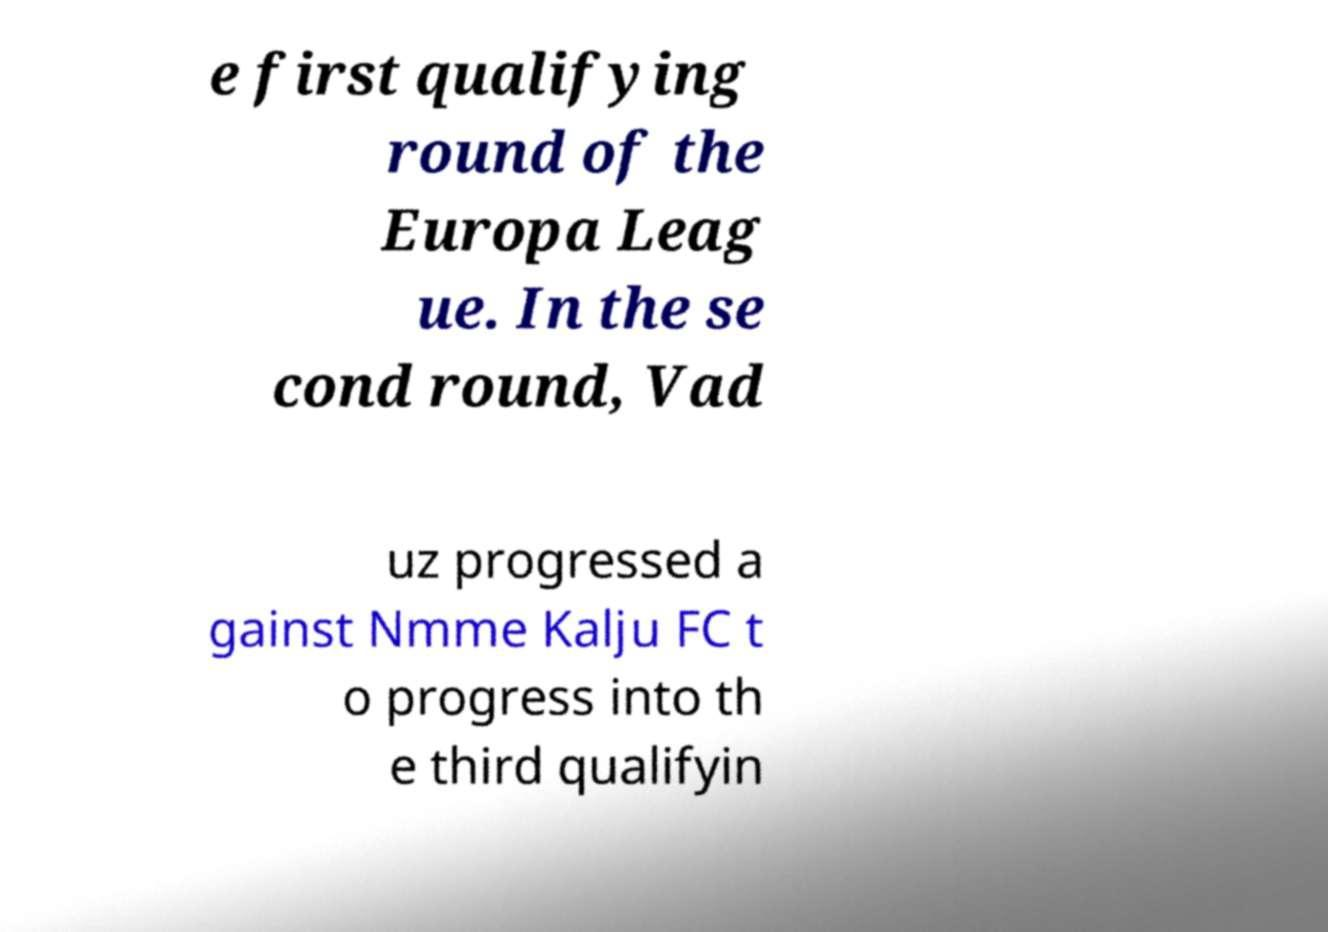Please identify and transcribe the text found in this image. e first qualifying round of the Europa Leag ue. In the se cond round, Vad uz progressed a gainst Nmme Kalju FC t o progress into th e third qualifyin 